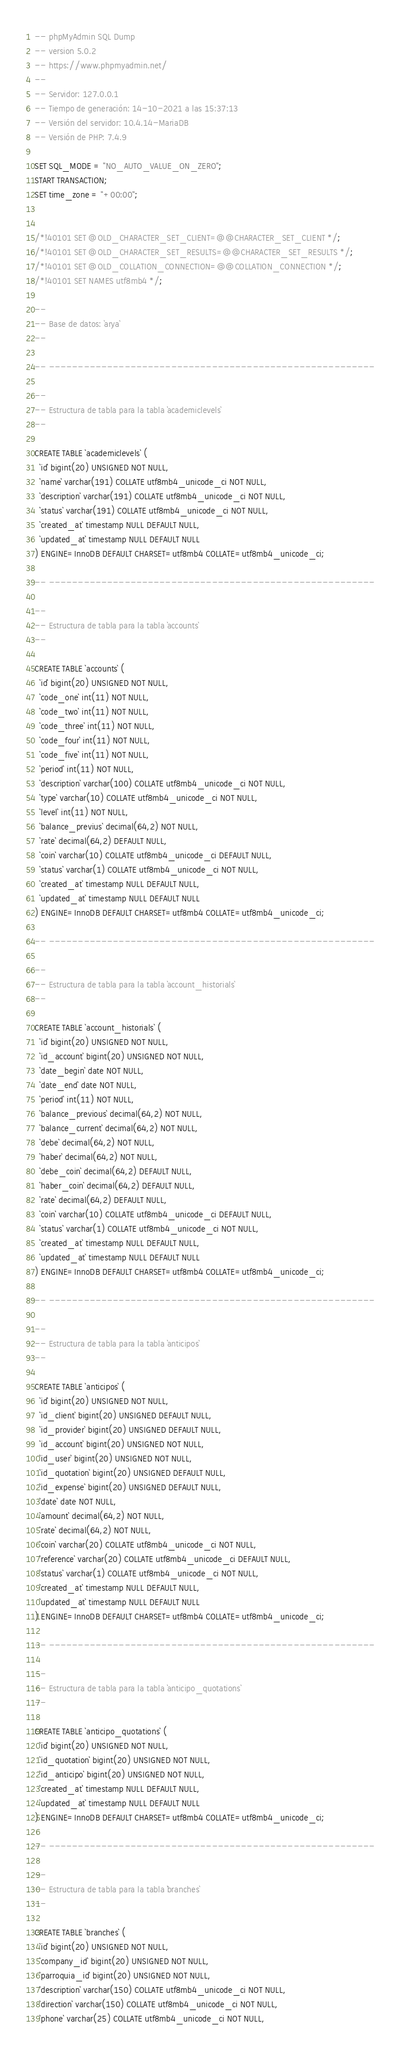<code> <loc_0><loc_0><loc_500><loc_500><_SQL_>-- phpMyAdmin SQL Dump
-- version 5.0.2
-- https://www.phpmyadmin.net/
--
-- Servidor: 127.0.0.1
-- Tiempo de generación: 14-10-2021 a las 15:37:13
-- Versión del servidor: 10.4.14-MariaDB
-- Versión de PHP: 7.4.9

SET SQL_MODE = "NO_AUTO_VALUE_ON_ZERO";
START TRANSACTION;
SET time_zone = "+00:00";


/*!40101 SET @OLD_CHARACTER_SET_CLIENT=@@CHARACTER_SET_CLIENT */;
/*!40101 SET @OLD_CHARACTER_SET_RESULTS=@@CHARACTER_SET_RESULTS */;
/*!40101 SET @OLD_COLLATION_CONNECTION=@@COLLATION_CONNECTION */;
/*!40101 SET NAMES utf8mb4 */;

--
-- Base de datos: `arya`
--

-- --------------------------------------------------------

--
-- Estructura de tabla para la tabla `academiclevels`
--

CREATE TABLE `academiclevels` (
  `id` bigint(20) UNSIGNED NOT NULL,
  `name` varchar(191) COLLATE utf8mb4_unicode_ci NOT NULL,
  `description` varchar(191) COLLATE utf8mb4_unicode_ci NOT NULL,
  `status` varchar(191) COLLATE utf8mb4_unicode_ci NOT NULL,
  `created_at` timestamp NULL DEFAULT NULL,
  `updated_at` timestamp NULL DEFAULT NULL
) ENGINE=InnoDB DEFAULT CHARSET=utf8mb4 COLLATE=utf8mb4_unicode_ci;

-- --------------------------------------------------------

--
-- Estructura de tabla para la tabla `accounts`
--

CREATE TABLE `accounts` (
  `id` bigint(20) UNSIGNED NOT NULL,
  `code_one` int(11) NOT NULL,
  `code_two` int(11) NOT NULL,
  `code_three` int(11) NOT NULL,
  `code_four` int(11) NOT NULL,
  `code_five` int(11) NOT NULL,
  `period` int(11) NOT NULL,
  `description` varchar(100) COLLATE utf8mb4_unicode_ci NOT NULL,
  `type` varchar(10) COLLATE utf8mb4_unicode_ci NOT NULL,
  `level` int(11) NOT NULL,
  `balance_previus` decimal(64,2) NOT NULL,
  `rate` decimal(64,2) DEFAULT NULL,
  `coin` varchar(10) COLLATE utf8mb4_unicode_ci DEFAULT NULL,
  `status` varchar(1) COLLATE utf8mb4_unicode_ci NOT NULL,
  `created_at` timestamp NULL DEFAULT NULL,
  `updated_at` timestamp NULL DEFAULT NULL
) ENGINE=InnoDB DEFAULT CHARSET=utf8mb4 COLLATE=utf8mb4_unicode_ci;

-- --------------------------------------------------------

--
-- Estructura de tabla para la tabla `account_historials`
--

CREATE TABLE `account_historials` (
  `id` bigint(20) UNSIGNED NOT NULL,
  `id_account` bigint(20) UNSIGNED NOT NULL,
  `date_begin` date NOT NULL,
  `date_end` date NOT NULL,
  `period` int(11) NOT NULL,
  `balance_previous` decimal(64,2) NOT NULL,
  `balance_current` decimal(64,2) NOT NULL,
  `debe` decimal(64,2) NOT NULL,
  `haber` decimal(64,2) NOT NULL,
  `debe_coin` decimal(64,2) DEFAULT NULL,
  `haber_coin` decimal(64,2) DEFAULT NULL,
  `rate` decimal(64,2) DEFAULT NULL,
  `coin` varchar(10) COLLATE utf8mb4_unicode_ci DEFAULT NULL,
  `status` varchar(1) COLLATE utf8mb4_unicode_ci NOT NULL,
  `created_at` timestamp NULL DEFAULT NULL,
  `updated_at` timestamp NULL DEFAULT NULL
) ENGINE=InnoDB DEFAULT CHARSET=utf8mb4 COLLATE=utf8mb4_unicode_ci;

-- --------------------------------------------------------

--
-- Estructura de tabla para la tabla `anticipos`
--

CREATE TABLE `anticipos` (
  `id` bigint(20) UNSIGNED NOT NULL,
  `id_client` bigint(20) UNSIGNED DEFAULT NULL,
  `id_provider` bigint(20) UNSIGNED DEFAULT NULL,
  `id_account` bigint(20) UNSIGNED NOT NULL,
  `id_user` bigint(20) UNSIGNED NOT NULL,
  `id_quotation` bigint(20) UNSIGNED DEFAULT NULL,
  `id_expense` bigint(20) UNSIGNED DEFAULT NULL,
  `date` date NOT NULL,
  `amount` decimal(64,2) NOT NULL,
  `rate` decimal(64,2) NOT NULL,
  `coin` varchar(20) COLLATE utf8mb4_unicode_ci NOT NULL,
  `reference` varchar(20) COLLATE utf8mb4_unicode_ci DEFAULT NULL,
  `status` varchar(1) COLLATE utf8mb4_unicode_ci NOT NULL,
  `created_at` timestamp NULL DEFAULT NULL,
  `updated_at` timestamp NULL DEFAULT NULL
) ENGINE=InnoDB DEFAULT CHARSET=utf8mb4 COLLATE=utf8mb4_unicode_ci;

-- --------------------------------------------------------

--
-- Estructura de tabla para la tabla `anticipo_quotations`
--

CREATE TABLE `anticipo_quotations` (
  `id` bigint(20) UNSIGNED NOT NULL,
  `id_quotation` bigint(20) UNSIGNED NOT NULL,
  `id_anticipo` bigint(20) UNSIGNED NOT NULL,
  `created_at` timestamp NULL DEFAULT NULL,
  `updated_at` timestamp NULL DEFAULT NULL
) ENGINE=InnoDB DEFAULT CHARSET=utf8mb4 COLLATE=utf8mb4_unicode_ci;

-- --------------------------------------------------------

--
-- Estructura de tabla para la tabla `branches`
--

CREATE TABLE `branches` (
  `id` bigint(20) UNSIGNED NOT NULL,
  `company_id` bigint(20) UNSIGNED NOT NULL,
  `parroquia_id` bigint(20) UNSIGNED NOT NULL,
  `description` varchar(150) COLLATE utf8mb4_unicode_ci NOT NULL,
  `direction` varchar(150) COLLATE utf8mb4_unicode_ci NOT NULL,
  `phone` varchar(25) COLLATE utf8mb4_unicode_ci NOT NULL,</code> 